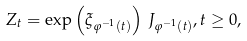Convert formula to latex. <formula><loc_0><loc_0><loc_500><loc_500>Z _ { t } = \exp \left ( \xi _ { \varphi ^ { - 1 } ( t ) } \right ) \, J _ { \varphi ^ { - 1 } ( t ) } , t \geq 0 ,</formula> 